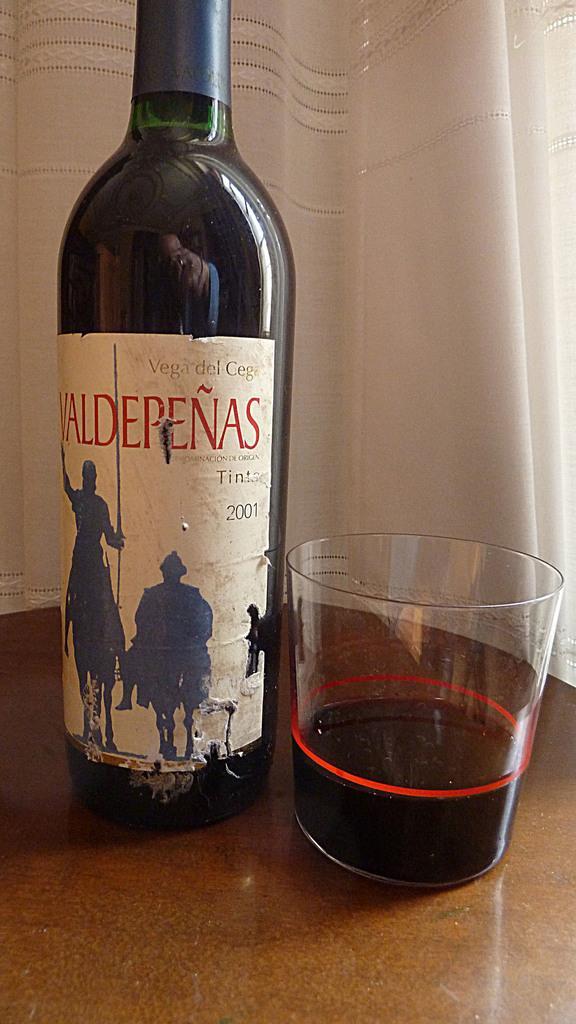Could you give a brief overview of what you see in this image? In this image there is a table and we can see a wine bottle and a glass placed on the table. In the background there is a curtain. 